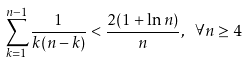<formula> <loc_0><loc_0><loc_500><loc_500>\sum _ { k = 1 } ^ { n - 1 } \frac { 1 } { k ( n - k ) } < \frac { 2 ( 1 + \ln n ) } { n } , \text { } \forall n \geq 4</formula> 